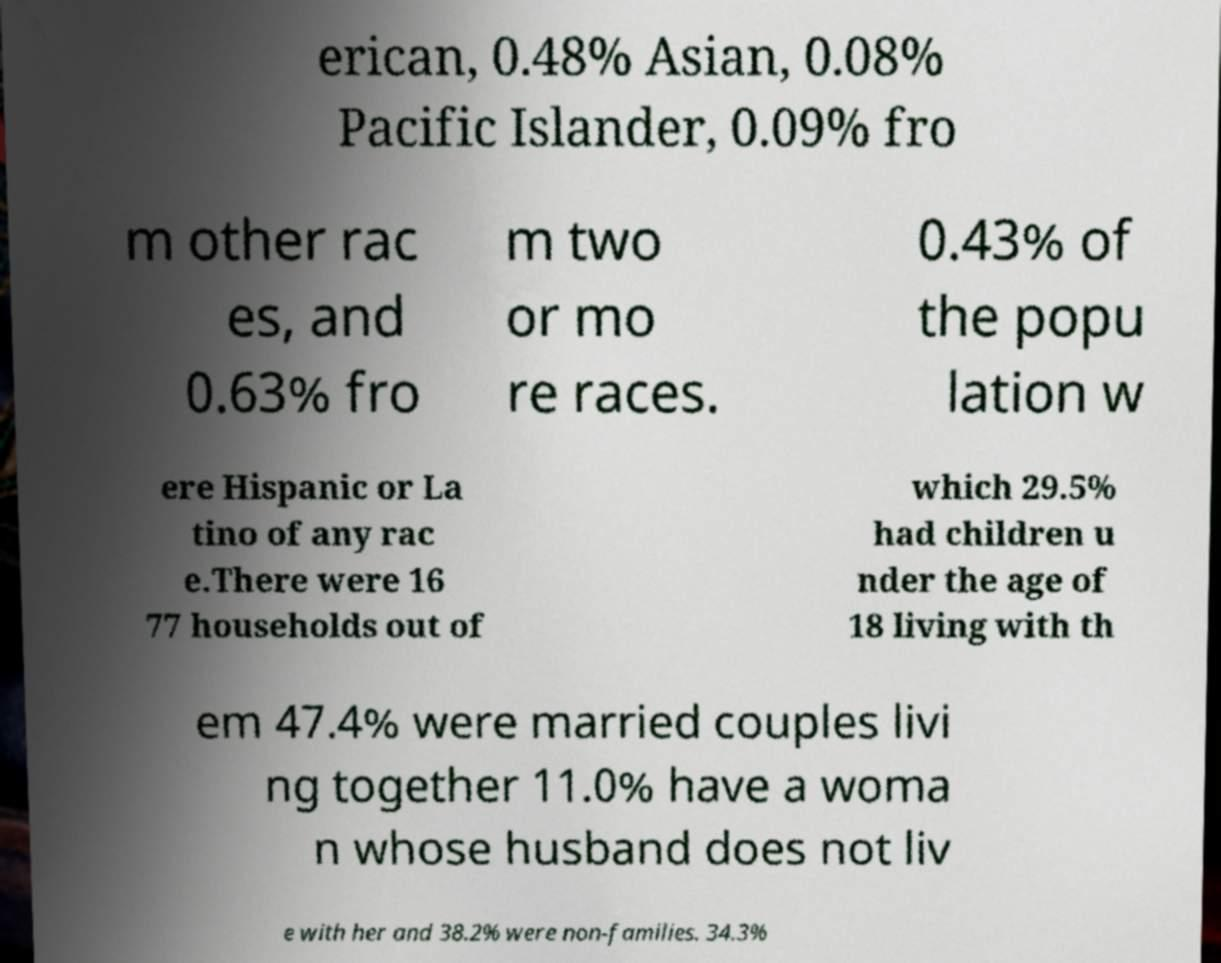There's text embedded in this image that I need extracted. Can you transcribe it verbatim? erican, 0.48% Asian, 0.08% Pacific Islander, 0.09% fro m other rac es, and 0.63% fro m two or mo re races. 0.43% of the popu lation w ere Hispanic or La tino of any rac e.There were 16 77 households out of which 29.5% had children u nder the age of 18 living with th em 47.4% were married couples livi ng together 11.0% have a woma n whose husband does not liv e with her and 38.2% were non-families. 34.3% 